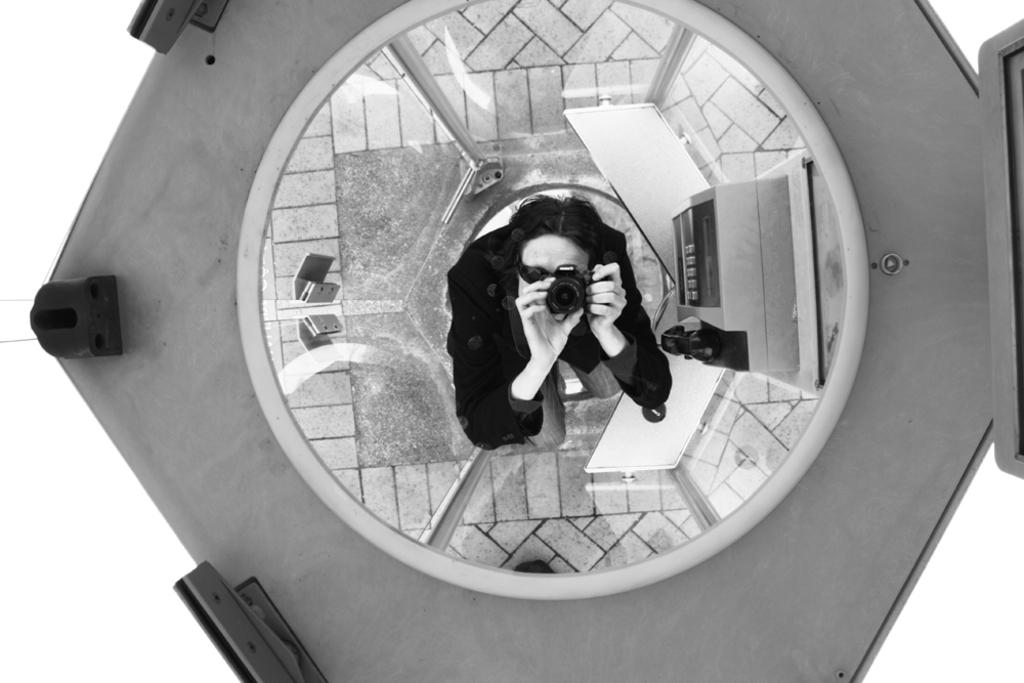What is the person in the image holding? The person in the image is holding a camera. What can be seen in the background of the image? There are objects visible in the background of the image, including glass doors. What is the color scheme of the image? The image is in black and white. Can you tell me how many snails are crawling on the glass doors in the image? There are no snails visible in the image, as it is focused on the person holding a camera and the objects in the background. 